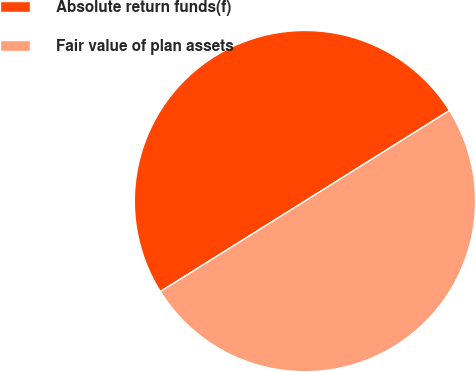<chart> <loc_0><loc_0><loc_500><loc_500><pie_chart><fcel>Absolute return funds(f)<fcel>Fair value of plan assets<nl><fcel>49.99%<fcel>50.01%<nl></chart> 